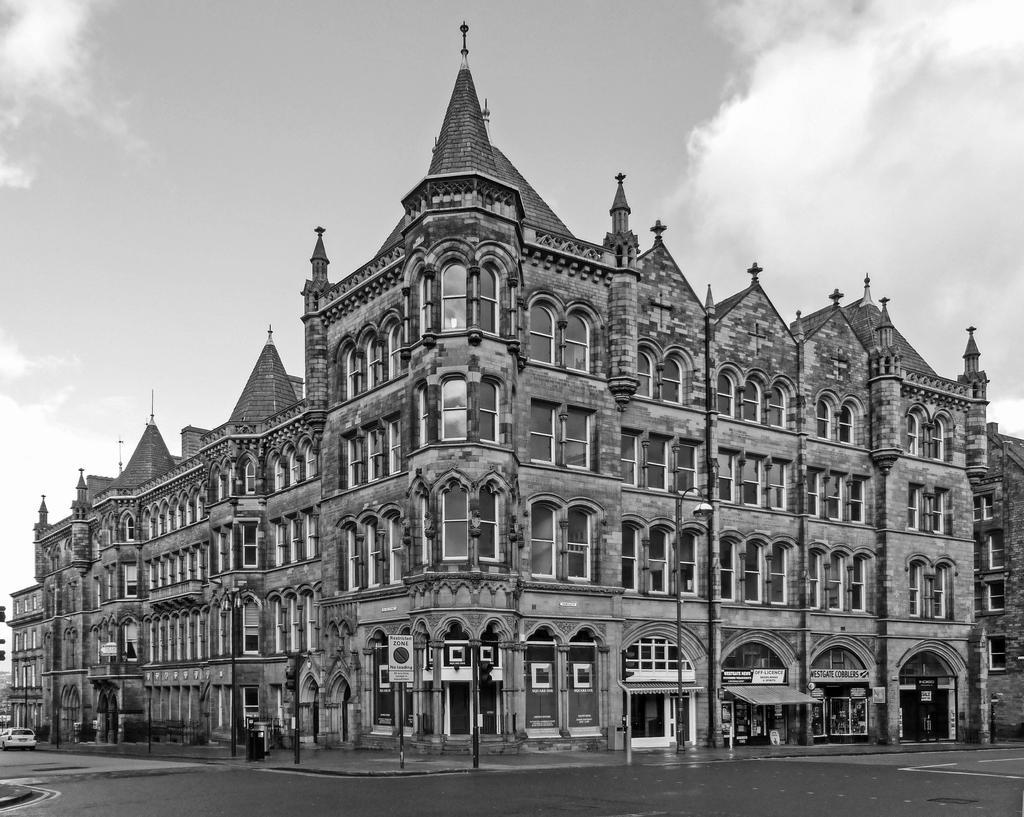Could you give a brief overview of what you see in this image? This is a black and white image. In the front of the image there is a building, vehicle and road. There are poles, boards and objects. Something is written on the boards. In the background of the image there is a cloudy sky.   